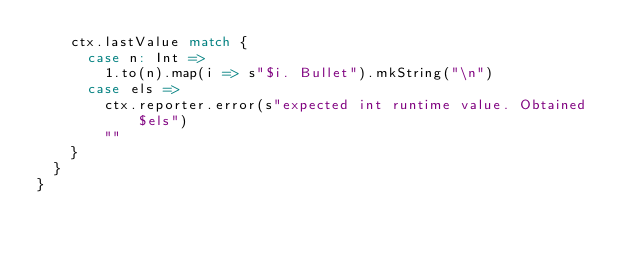<code> <loc_0><loc_0><loc_500><loc_500><_Scala_>    ctx.lastValue match {
      case n: Int =>
        1.to(n).map(i => s"$i. Bullet").mkString("\n")
      case els =>
        ctx.reporter.error(s"expected int runtime value. Obtained $els")
        ""
    }
  }
}
</code> 